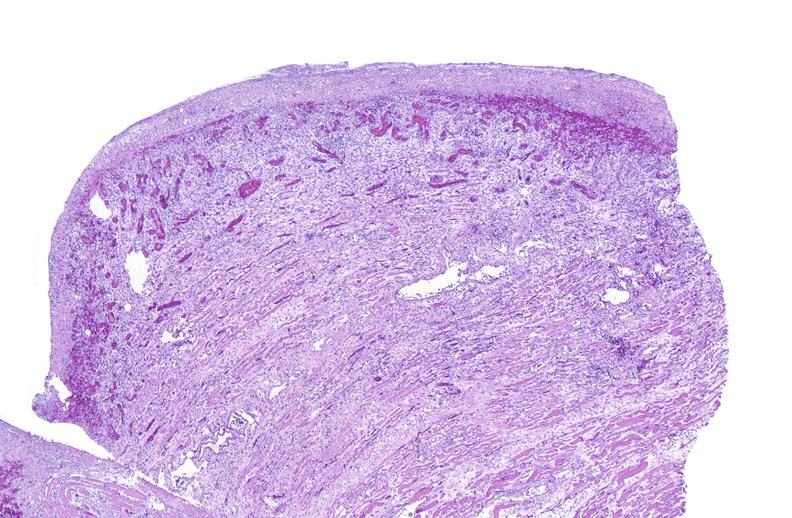s soft tissue present?
Answer the question using a single word or phrase. Yes 